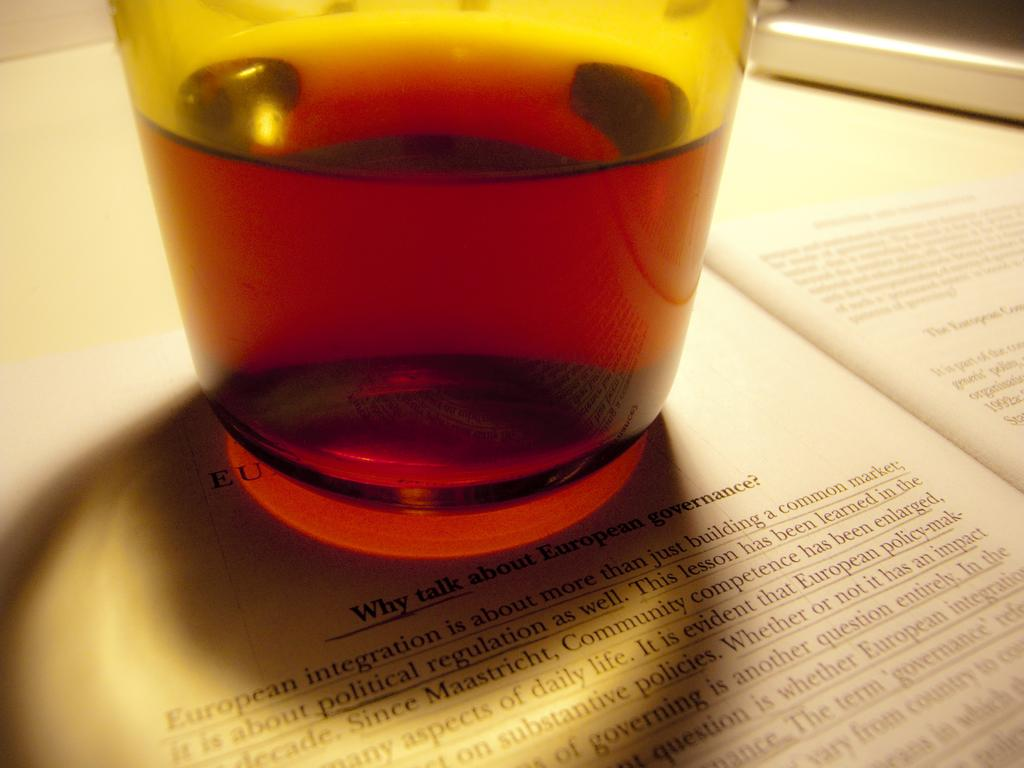<image>
Render a clear and concise summary of the photo. A glass on top of a Why talk about heading article 